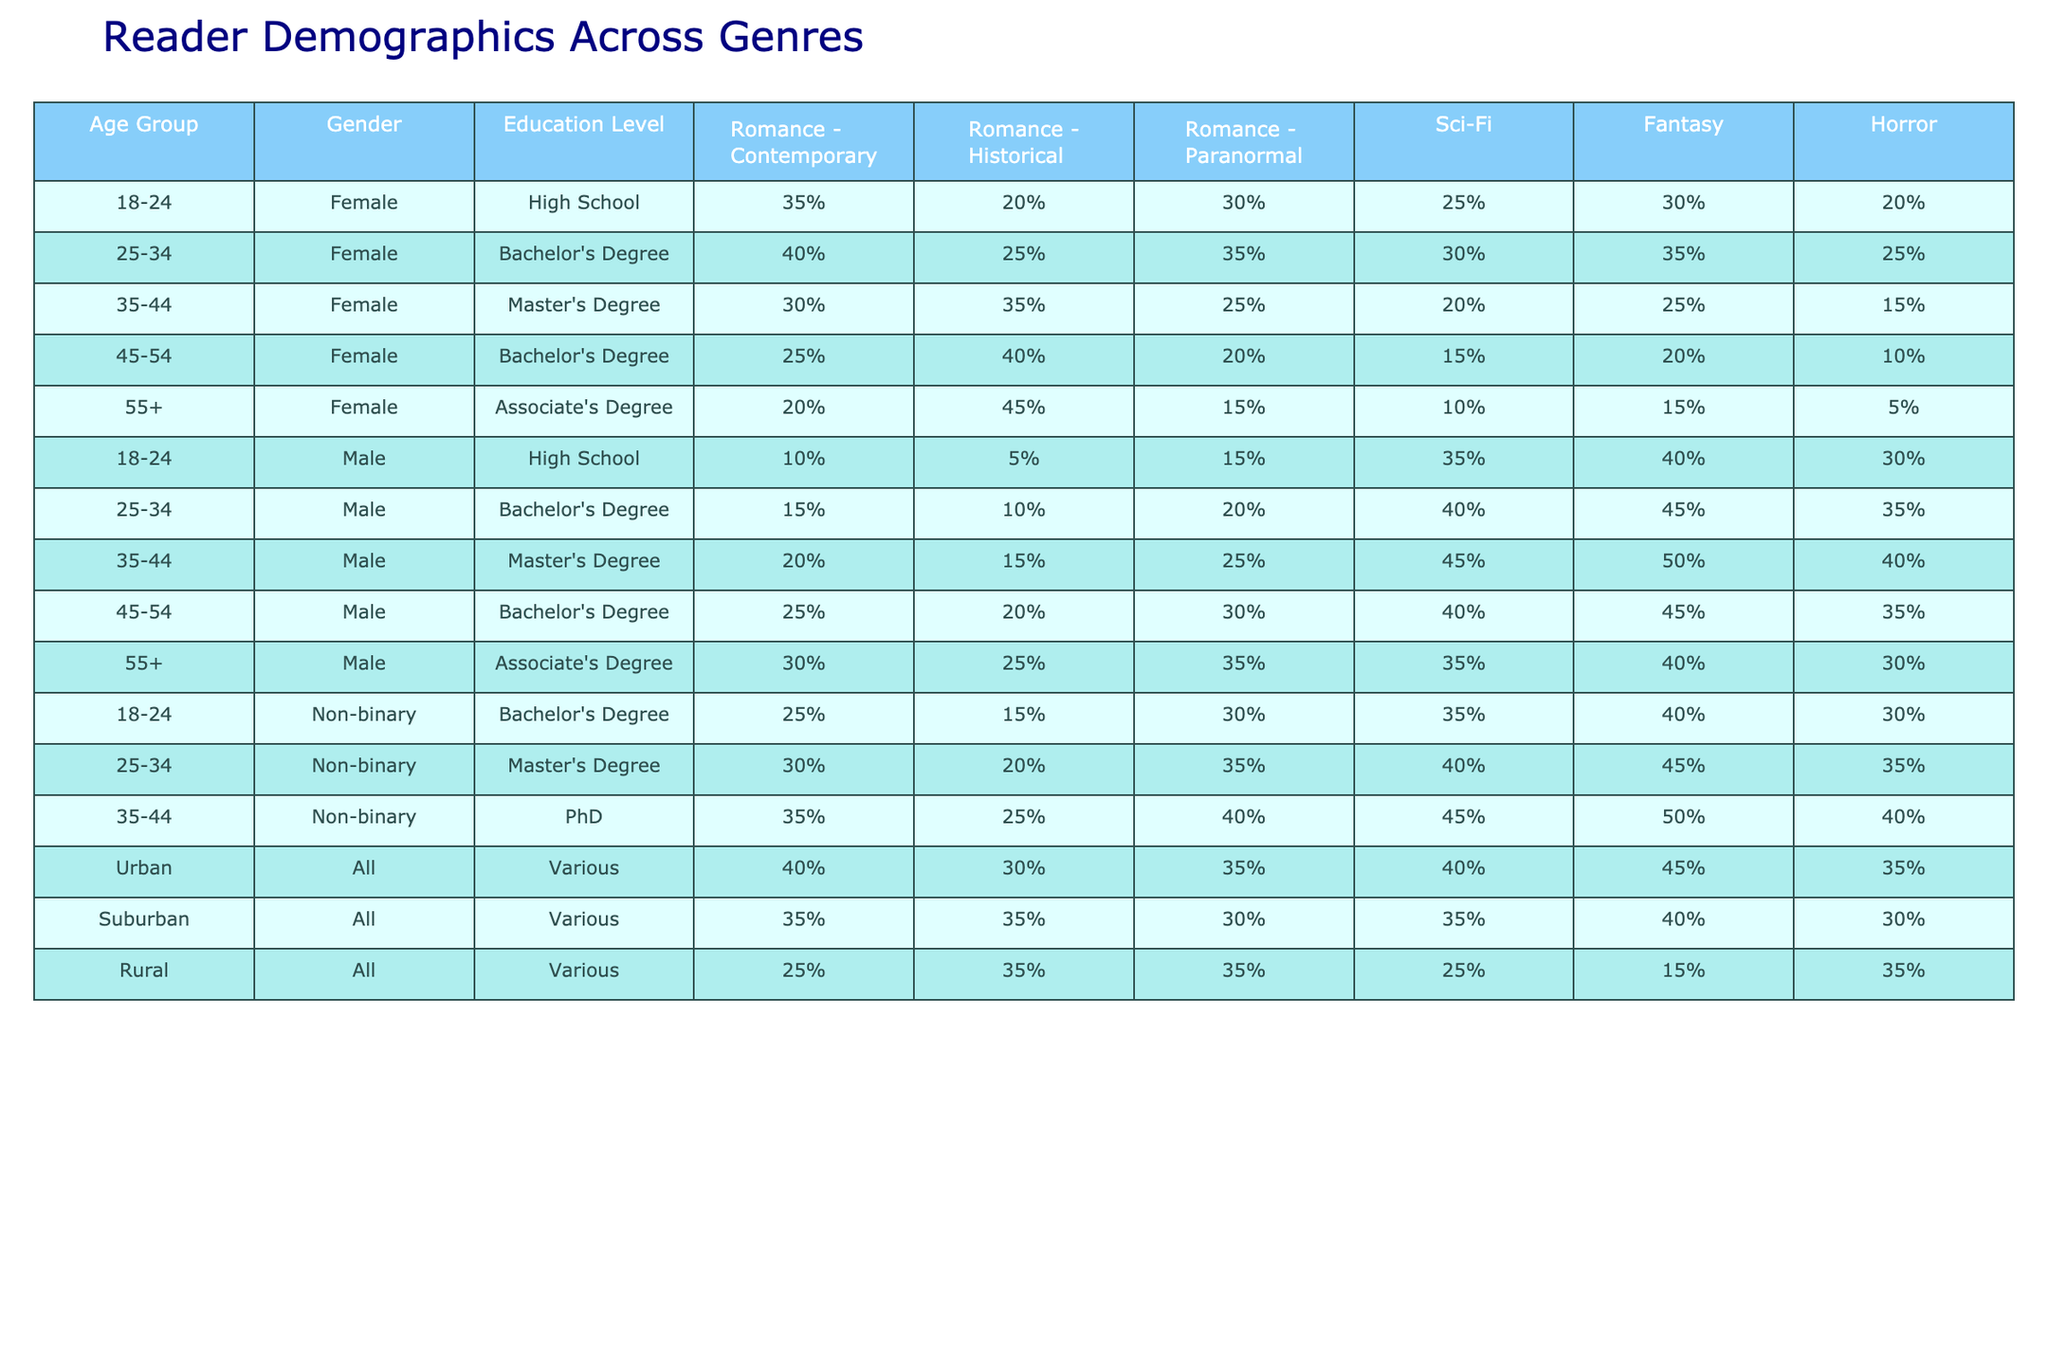What percentage of 25-34-year-old females prefer historical romance? Looking at the row for 25-34-year-old females, the value corresponding to historical romance is 25%.
Answer: 25% Which gender shows the highest preference for science fiction in the age group 35-44? In the 35-44 age group, males have a preference of 45% for science fiction, which is higher than the 20% for females and 45% for non-binary.
Answer: Males What is the difference in percentage preference for contemporary romance between urban and suburban readers? For urban readers, the percentage for contemporary romance is 40%, while for suburban readers, it is 35%. The difference is 40% - 35% = 5%.
Answer: 5% Is it true that the horror genre has a higher preference among rural readers than among females aged 55 and older? The horror preference among rural readers is 35%, while for females aged 55+, it is only 5%. Thus, the statement is true.
Answer: Yes What is the average percentage preference for paranormal romance across all age groups for females? The percentages for paranormal romance for females across all age groups are: 30%, 35%, 25%, 20%, 15%. The total is 30 + 35 + 25 + 20 + 15 = 125%. The average is 125% / 5 = 25%.
Answer: 25% Which age group and gender combination has the lowest preference for fantasy? Looking across all groups, females aged 55 and older have the lowest preference for fantasy at 15%.
Answer: Females aged 55+ Compare the highest and lowest percentage preferences for sci-fi among males. Males aged 35-44 have the highest preference for sci-fi at 45%, while those aged 18-24 have the lowest preference at 35%. The difference is 45% - 35% = 10%.
Answer: 10% For non-binary readers, what genre has the highest overall percentage preference? Looking at the non-binary row, fantasy has the highest percentage preference at 50%.
Answer: Fantasy How does the average percentage preference for historical romance of 45-54-year-olds compare between males and females? For males aged 45-54, it is 20% while for females it is 40%. So the difference indicates females have a higher preference by 20%.
Answer: Males 20%, Females 40% What genre has the same preference percentage among urban and rural readers? Upon closer inspection, both urban and rural readers have a 35% preference for horror.
Answer: Horror Which education level shows the highest interest in contemporary romance regardless of gender? The row with various genders and education levels indicates that those with a high school education have the highest preference for contemporary romance at 40%.
Answer: High School 